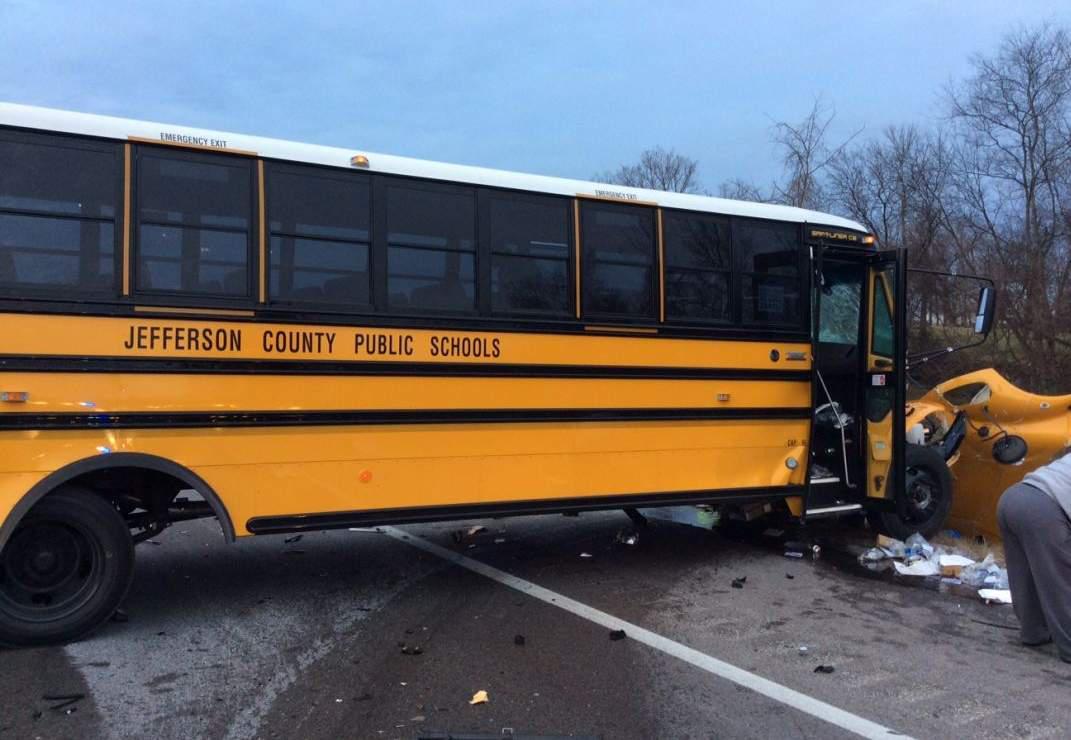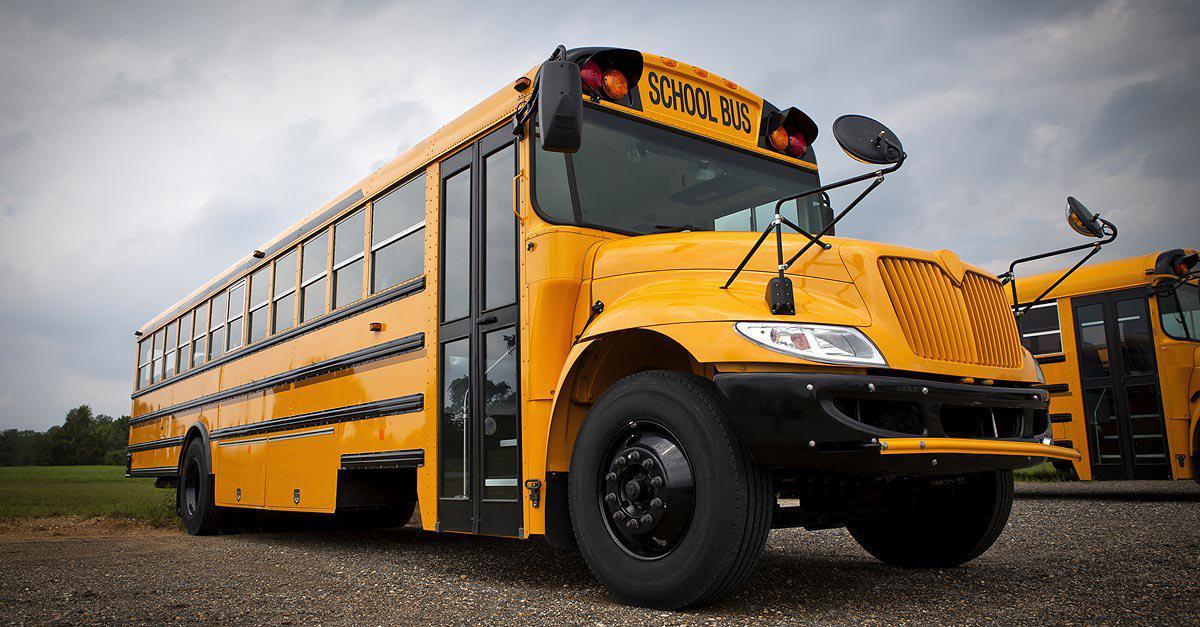The first image is the image on the left, the second image is the image on the right. Examine the images to the left and right. Is the description "In the right image, a rightward-facing yellow bus appears to be colliding with something else that is yellow." accurate? Answer yes or no. Yes. 